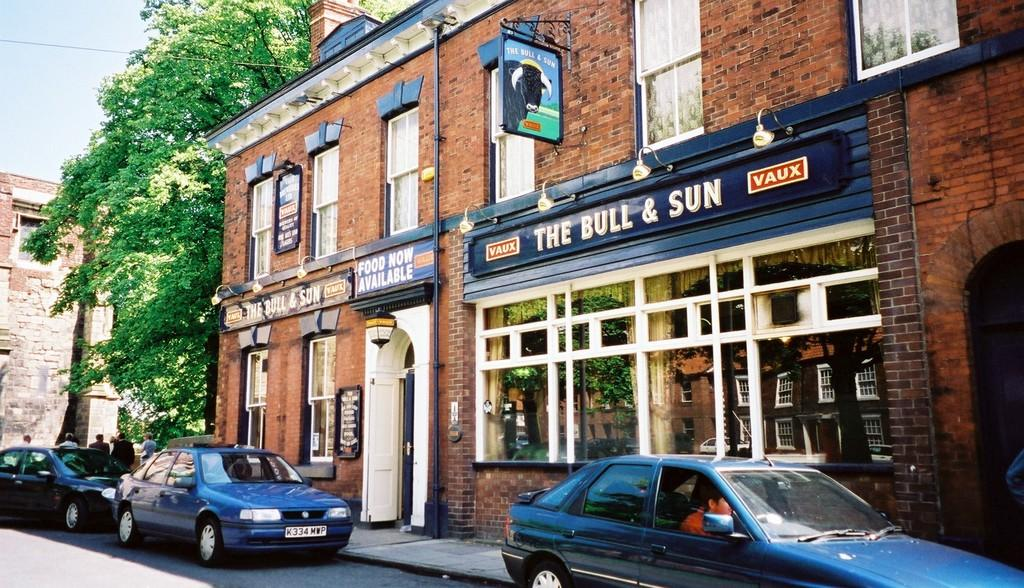What can be seen on the road in the image? There are cars on the road in the image. What type of structures are visible in the image? There are buildings with windows in the image. What additional elements can be seen in the image? There are banners and trees in the image. Are there any people present in the image? Yes, there are persons in the image. What is visible in the background of the image? The sky is visible in the background of the image. What type of popcorn is being shared among the persons in the image? There is no popcorn present in the image; it features cars, buildings, banners, trees, and persons. How is the division of labor represented in the image? The image does not depict any division of labor or work-related activities. 